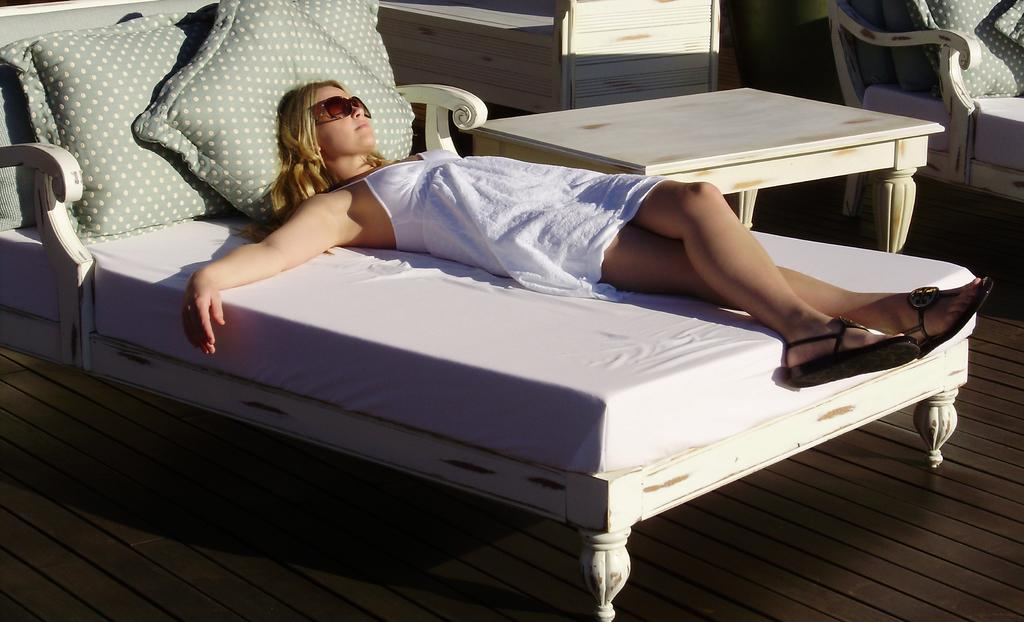What is the woman doing in the image? The woman is lying on the bed in the image. What accessories is the woman wearing? The woman is wearing flippers and goggles. How many pillows are on the bed? There are three pillows on the bed. What is located next to the bed? There is a table next to the bed. What type of art can be seen on the wall behind the woman? There is no art visible on the wall behind the woman in the image. 